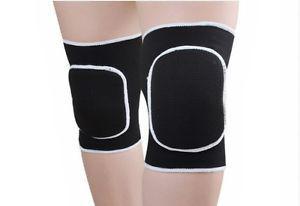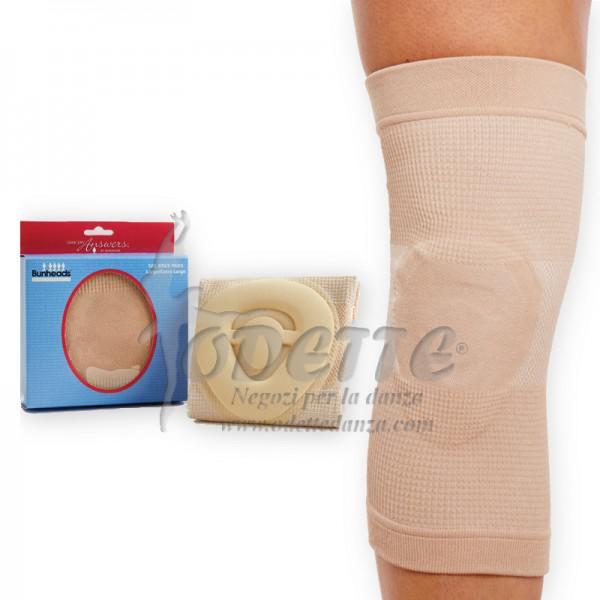The first image is the image on the left, the second image is the image on the right. For the images shown, is this caption "Each image contains a pair of legs with the leg on the left bent and overlapping the right leg, and each image includes at least one hot pink knee pad." true? Answer yes or no. No. The first image is the image on the left, the second image is the image on the right. For the images shown, is this caption "There is at least one unworn knee pad to the right of a model's legs." true? Answer yes or no. No. 